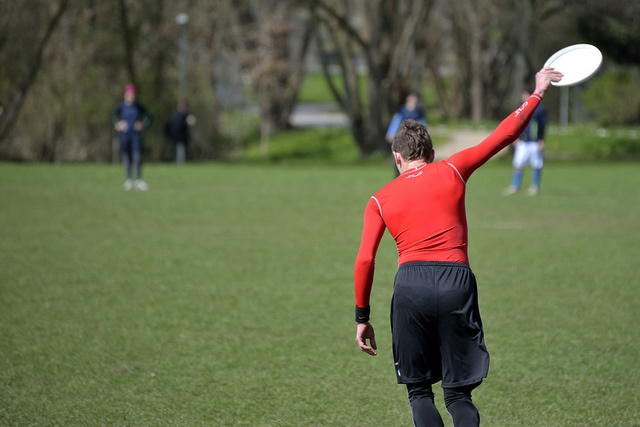Describe the objects in this image and their specific colors. I can see people in black, salmon, red, and gray tones, people in black, gray, navy, and darkblue tones, people in black, gray, darkgray, and lavender tones, frisbee in black, white, gray, and darkgray tones, and people in black, gray, and purple tones in this image. 